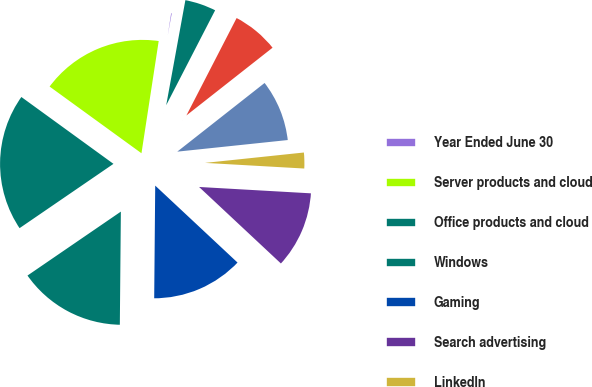Convert chart. <chart><loc_0><loc_0><loc_500><loc_500><pie_chart><fcel>Year Ended June 30<fcel>Server products and cloud<fcel>Office products and cloud<fcel>Windows<fcel>Gaming<fcel>Search advertising<fcel>LinkedIn<fcel>Enterprise Services<fcel>Devices<fcel>Other<nl><fcel>0.45%<fcel>17.43%<fcel>19.55%<fcel>15.3%<fcel>13.18%<fcel>11.06%<fcel>2.57%<fcel>8.94%<fcel>6.82%<fcel>4.7%<nl></chart> 